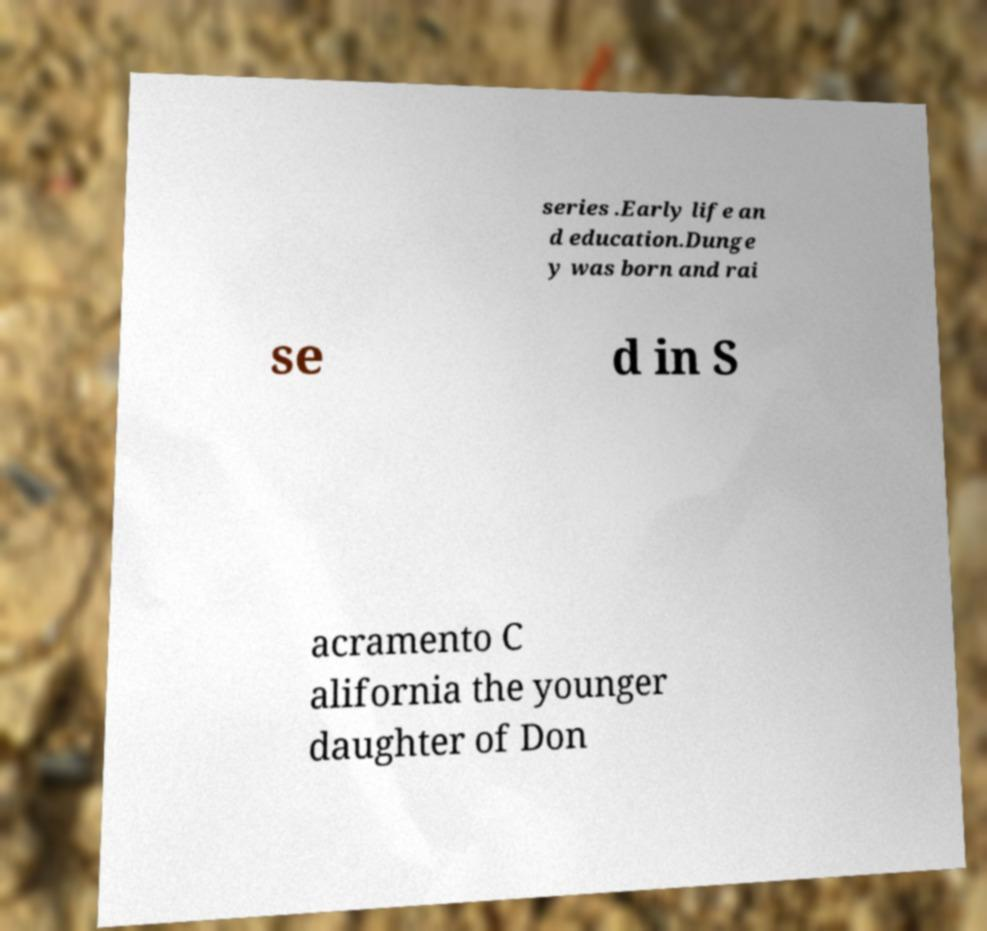For documentation purposes, I need the text within this image transcribed. Could you provide that? series .Early life an d education.Dunge y was born and rai se d in S acramento C alifornia the younger daughter of Don 